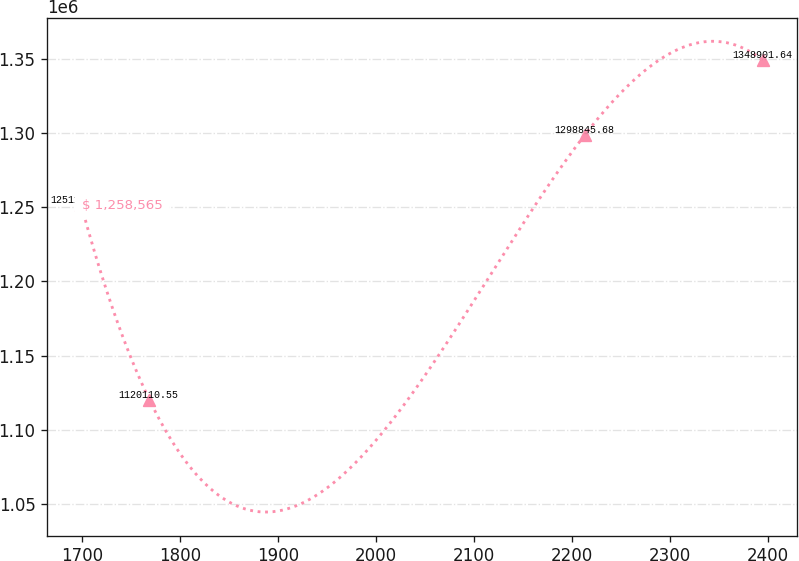Convert chart to OTSL. <chart><loc_0><loc_0><loc_500><loc_500><line_chart><ecel><fcel>$ 1,258,565<nl><fcel>1699.3<fcel>1.25114e+06<nl><fcel>1768.87<fcel>1.12011e+06<nl><fcel>2213.39<fcel>1.29885e+06<nl><fcel>2395.03<fcel>1.3489e+06<nl></chart> 